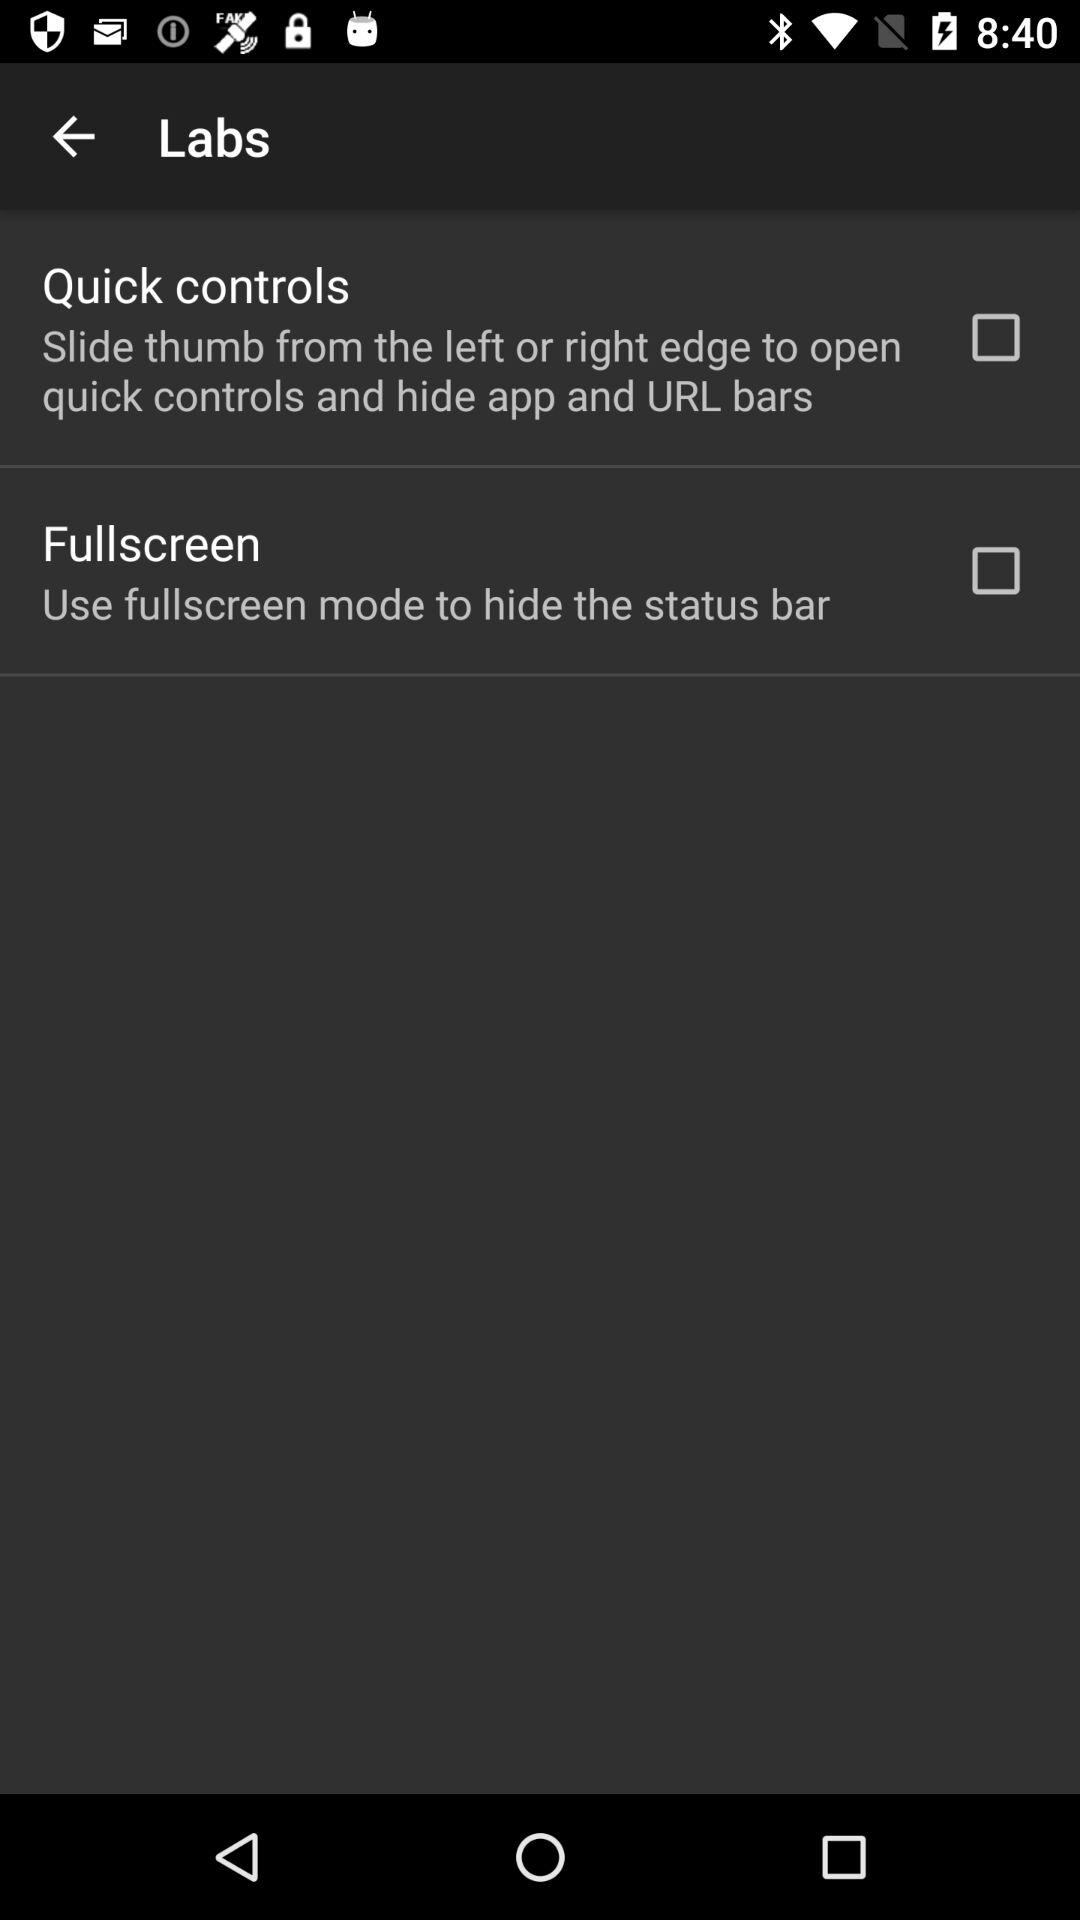What is the status of "Quick controls"? The status of "Quick controls" is "off". 